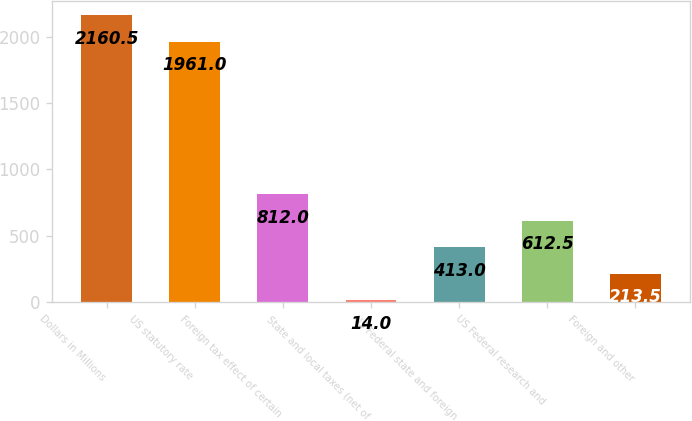Convert chart to OTSL. <chart><loc_0><loc_0><loc_500><loc_500><bar_chart><fcel>Dollars in Millions<fcel>US statutory rate<fcel>Foreign tax effect of certain<fcel>State and local taxes (net of<fcel>US Federal state and foreign<fcel>US Federal research and<fcel>Foreign and other<nl><fcel>2160.5<fcel>1961<fcel>812<fcel>14<fcel>413<fcel>612.5<fcel>213.5<nl></chart> 